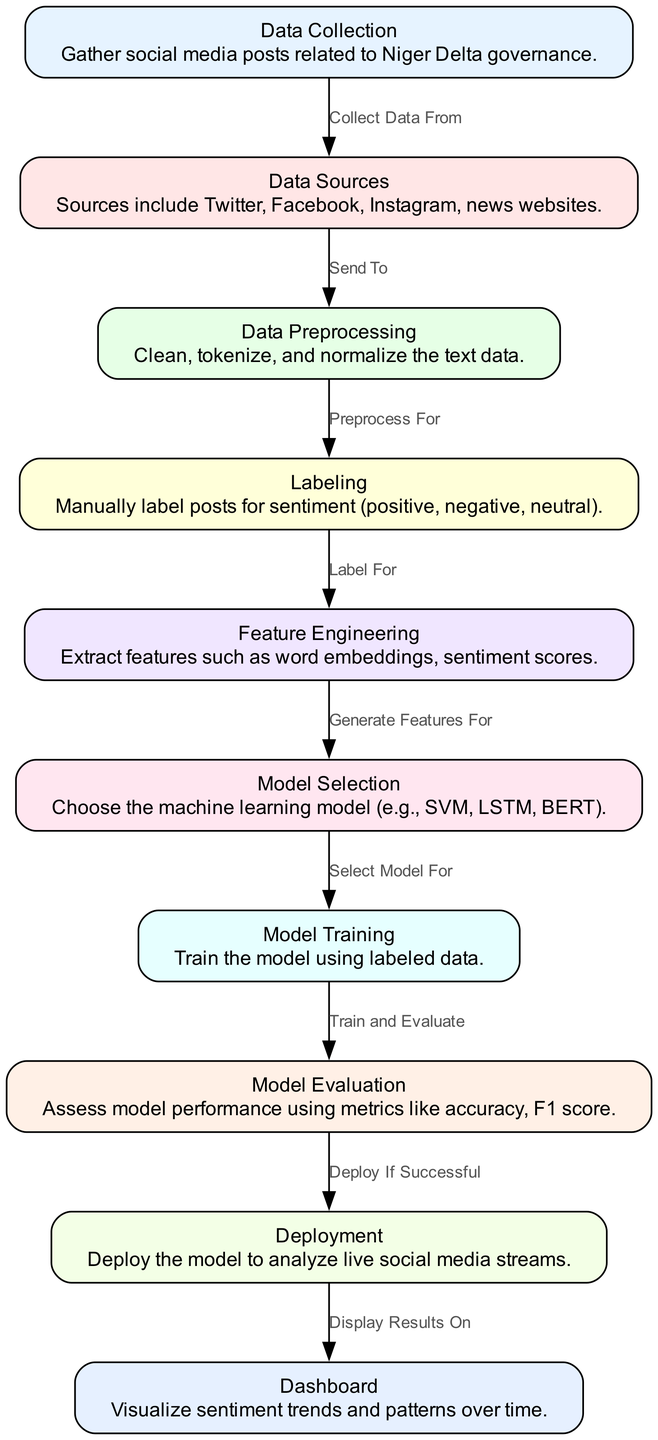What are the data sources used for sentiment analysis? The diagram specifically lists Twitter, Facebook, Instagram, and news websites as the sources for data collection. These platforms are crucial for gathering social media posts relevant to Niger Delta governance sentiments.
Answer: Twitter, Facebook, Instagram, news websites How many nodes are present in this diagram? By counting the distinct labeled nodes in the diagram, we observe 10 different nodes representing various stages in the sentiment analysis process, from data collection to the dashboard.
Answer: 10 Which node comes immediately after "Data Preprocessing"? The edge leading from the "Data Preprocessing" node points to the "Labeling" node. This shows that preprocessing is done in preparation for labeling the cleaned text data for sentiment.
Answer: Labeling What type of model is selected in the "Model Selection" node? The diagram indicates that machine learning models such as SVM, LSTM, and BERT are considered for selection. This encompasses a variety of approaches suitable for processing sentiment analysis.
Answer: SVM, LSTM, BERT What action is taken after the "Model Evaluation"? After evaluating the model's performance, if successful, the next action indicated is "Deployment." This step involves applying the trained model in real-time settings for analyzing live data streams.
Answer: Deployment Which node generates features for model training? The "Feature Engineering" node is specifically responsible for feature extraction needed for the subsequent model training step, where these features will inform the model's learning process.
Answer: Feature Engineering How is the data sent from data sources to preprocessing? The directed edge between the "Data Sources" node and the "Data Preprocessing" node explicitly states that data is sent to preprocessing after being collected from social media posts.
Answer: Send To What is visualized in the "Dashboard" node? The dashboard is designed to visualize sentiment trends and patterns over time, providing insights into public sentiment regarding governance issues in the Niger Delta.
Answer: Sentiment trends and patterns over time What metrics are used for model evaluation? The diagram notes that metrics for model evaluation include accuracy and F1 score, which are standard measures for assessing the performance of machine learning models.
Answer: Accuracy, F1 score 